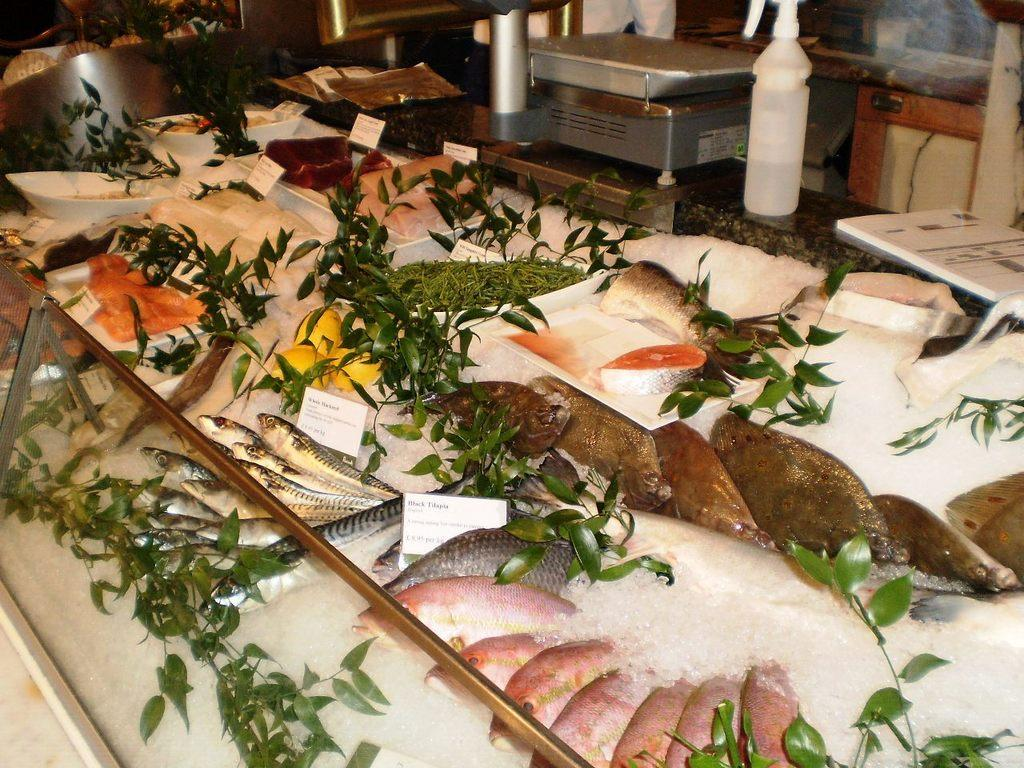What types of living organisms can be seen in the image? Plants and fishes are visible in the image. What is the glass object containing in the image? There are ice pieces in a glass object in the image. Can you describe the background of the image? There are other things visible in the background of the image, but specific details are not provided. What sense is being stimulated by the vacation in the image? There is no mention of a vacation in the image, so it is not possible to determine which sense might be stimulated. 